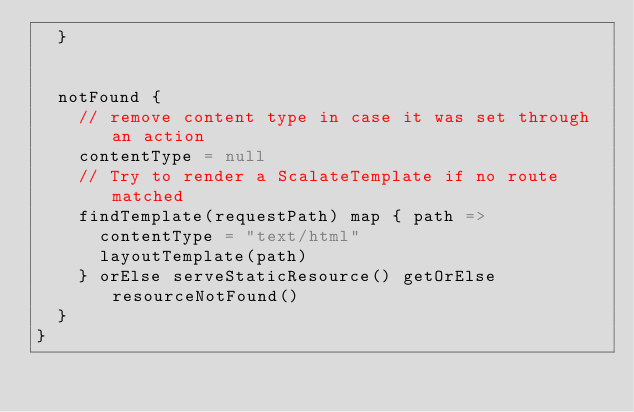Convert code to text. <code><loc_0><loc_0><loc_500><loc_500><_Scala_>  }
  

  notFound {
    // remove content type in case it was set through an action
    contentType = null
    // Try to render a ScalateTemplate if no route matched
    findTemplate(requestPath) map { path =>
      contentType = "text/html"
      layoutTemplate(path)
    } orElse serveStaticResource() getOrElse resourceNotFound()
  }
}
</code> 